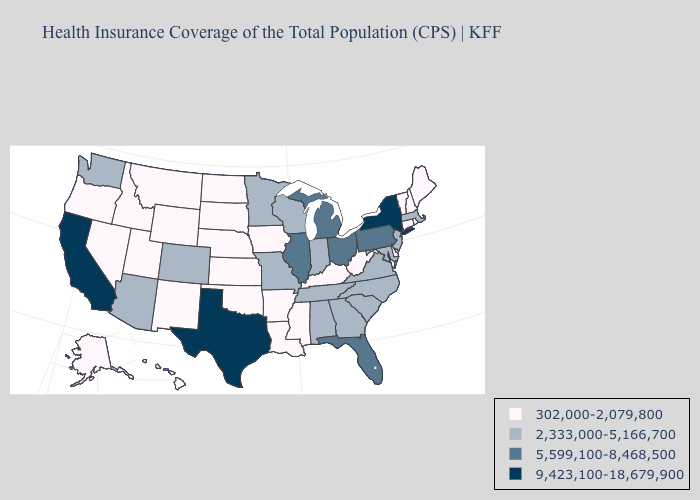What is the lowest value in the MidWest?
Concise answer only. 302,000-2,079,800. Among the states that border Pennsylvania , does Maryland have the highest value?
Answer briefly. No. Does Iowa have a lower value than Louisiana?
Quick response, please. No. Name the states that have a value in the range 5,599,100-8,468,500?
Be succinct. Florida, Illinois, Michigan, Ohio, Pennsylvania. Name the states that have a value in the range 302,000-2,079,800?
Concise answer only. Alaska, Arkansas, Connecticut, Delaware, Hawaii, Idaho, Iowa, Kansas, Kentucky, Louisiana, Maine, Mississippi, Montana, Nebraska, Nevada, New Hampshire, New Mexico, North Dakota, Oklahoma, Oregon, Rhode Island, South Dakota, Utah, Vermont, West Virginia, Wyoming. What is the value of Missouri?
Be succinct. 2,333,000-5,166,700. Among the states that border South Dakota , does Minnesota have the lowest value?
Concise answer only. No. Among the states that border Alabama , does Florida have the lowest value?
Write a very short answer. No. Does Massachusetts have the lowest value in the Northeast?
Keep it brief. No. Does Idaho have the same value as Alaska?
Quick response, please. Yes. Does Michigan have the highest value in the MidWest?
Short answer required. Yes. Which states have the lowest value in the Northeast?
Be succinct. Connecticut, Maine, New Hampshire, Rhode Island, Vermont. What is the highest value in the USA?
Keep it brief. 9,423,100-18,679,900. Name the states that have a value in the range 5,599,100-8,468,500?
Keep it brief. Florida, Illinois, Michigan, Ohio, Pennsylvania. Does Virginia have a higher value than Ohio?
Be succinct. No. 